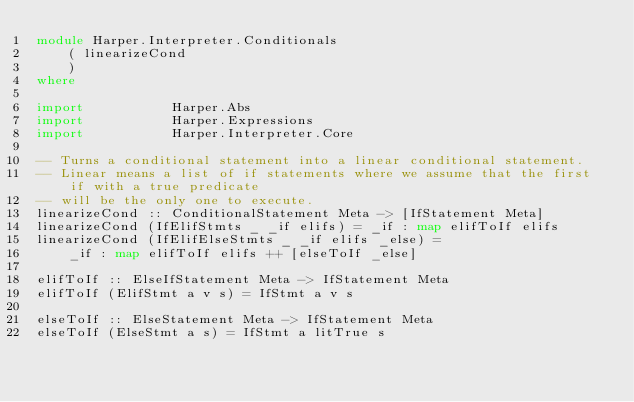Convert code to text. <code><loc_0><loc_0><loc_500><loc_500><_Haskell_>module Harper.Interpreter.Conditionals
    ( linearizeCond
    )
where

import           Harper.Abs
import           Harper.Expressions
import           Harper.Interpreter.Core

-- Turns a conditional statement into a linear conditional statement.
-- Linear means a list of if statements where we assume that the first if with a true predicate
-- will be the only one to execute.
linearizeCond :: ConditionalStatement Meta -> [IfStatement Meta]
linearizeCond (IfElifStmts _ _if elifs) = _if : map elifToIf elifs
linearizeCond (IfElifElseStmts _ _if elifs _else) =
    _if : map elifToIf elifs ++ [elseToIf _else]

elifToIf :: ElseIfStatement Meta -> IfStatement Meta
elifToIf (ElifStmt a v s) = IfStmt a v s

elseToIf :: ElseStatement Meta -> IfStatement Meta
elseToIf (ElseStmt a s) = IfStmt a litTrue s
</code> 